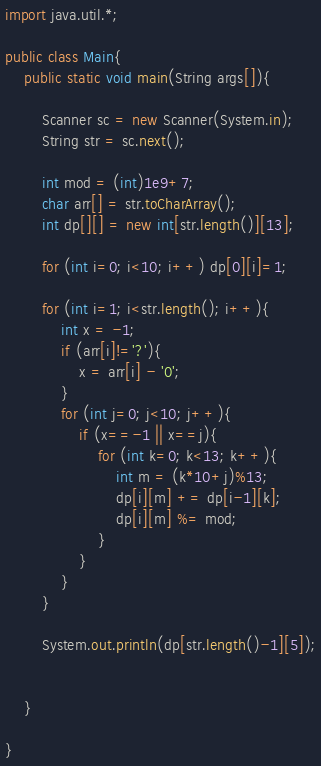<code> <loc_0><loc_0><loc_500><loc_500><_Java_>import java.util.*;

public class Main{
    public static void main(String args[]){

        Scanner sc = new Scanner(System.in);
        String str = sc.next();

        int mod = (int)1e9+7;
        char arr[] = str.toCharArray();
        int dp[][] = new int[str.length()][13];

        for (int i=0; i<10; i++) dp[0][i]=1;

        for (int i=1; i<str.length(); i++){
            int x = -1;
            if (arr[i]!='?'){
                x = arr[i] - '0';
            }
            for (int j=0; j<10; j++){
                if (x==-1 || x==j){
                    for (int k=0; k<13; k++){
                        int m = (k*10+j)%13;
                        dp[i][m] += dp[i-1][k];
                        dp[i][m] %= mod;
                    }
                }
            }
        }

        System.out.println(dp[str.length()-1][5]);


    }

}	</code> 